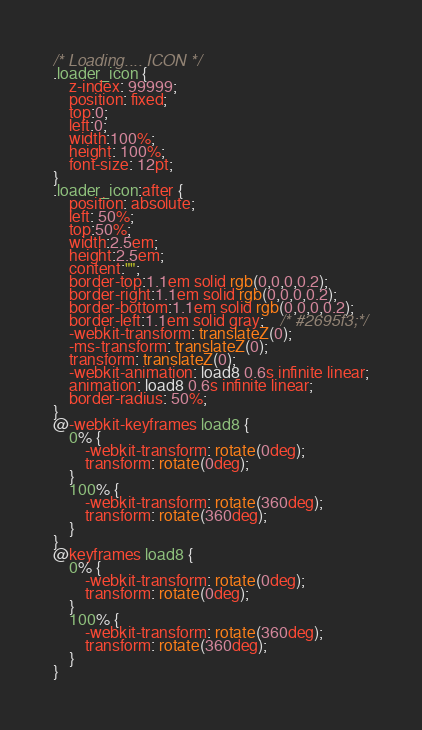<code> <loc_0><loc_0><loc_500><loc_500><_CSS_>/* Loading.... ICON */
.loader_icon {
	z-index: 99999;
	position: fixed;
	top:0;
	left:0;
	width:100%;
	height: 100%;
	font-size: 12pt;
}
.loader_icon:after {
	position: absolute;
	left: 50%;
	top:50%;
	width:2.5em;
	height:2.5em;
	content:"";
	border-top:1.1em solid rgb(0,0,0,0.2);
	border-right:1.1em solid rgb(0,0,0,0.2);
	border-bottom:1.1em solid rgb(0,0,0,0.2);
	border-left:1.1em solid gray;	/* #2695f3;*/
	-webkit-transform: translateZ(0);
	-ms-transform: translateZ(0);
	transform: translateZ(0);
	-webkit-animation: load8 0.6s infinite linear;
	animation: load8 0.6s infinite linear;
	border-radius: 50%;
}
@-webkit-keyframes load8 {
	0% {
		-webkit-transform: rotate(0deg);
		transform: rotate(0deg);
	}
	100% {
		-webkit-transform: rotate(360deg);
		transform: rotate(360deg);
	}
}
@keyframes load8 {
	0% {
		-webkit-transform: rotate(0deg);
		transform: rotate(0deg);
	}
	100% {
		-webkit-transform: rotate(360deg);
		transform: rotate(360deg);
	}
}
</code> 